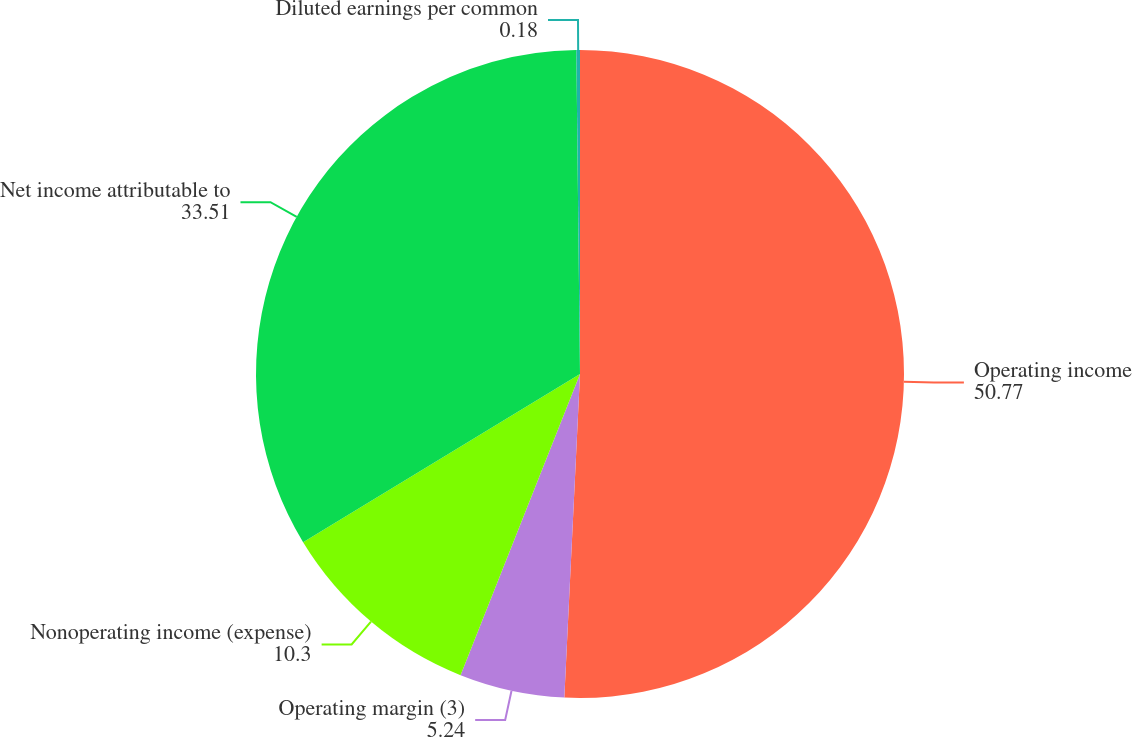Convert chart. <chart><loc_0><loc_0><loc_500><loc_500><pie_chart><fcel>Operating income<fcel>Operating margin (3)<fcel>Nonoperating income (expense)<fcel>Net income attributable to<fcel>Diluted earnings per common<nl><fcel>50.77%<fcel>5.24%<fcel>10.3%<fcel>33.51%<fcel>0.18%<nl></chart> 